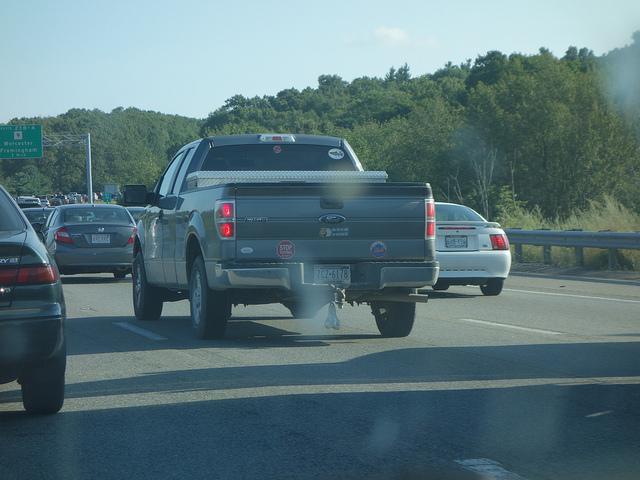What color is the truck?
Short answer required. Gray. Was this photo taken from inside of a vehicle?
Quick response, please. Yes. What make is this truck?
Quick response, please. Ford. Is there lots of traffic there?
Give a very brief answer. Yes. 